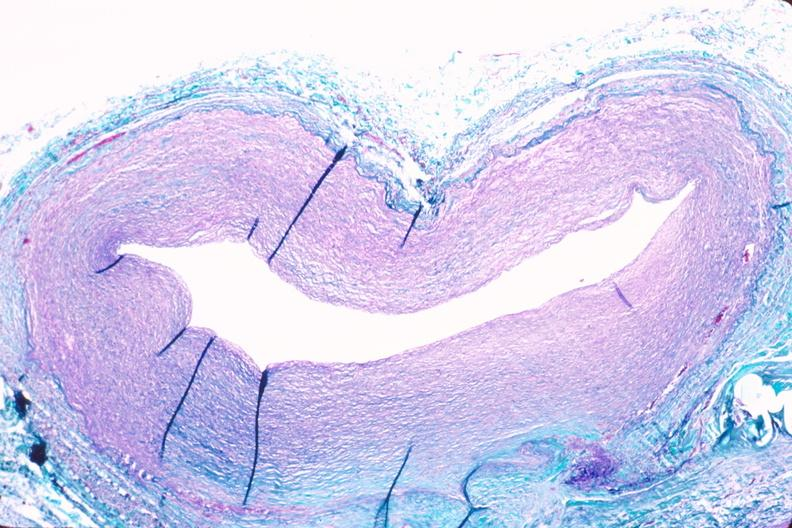what is present?
Answer the question using a single word or phrase. Vasculature 